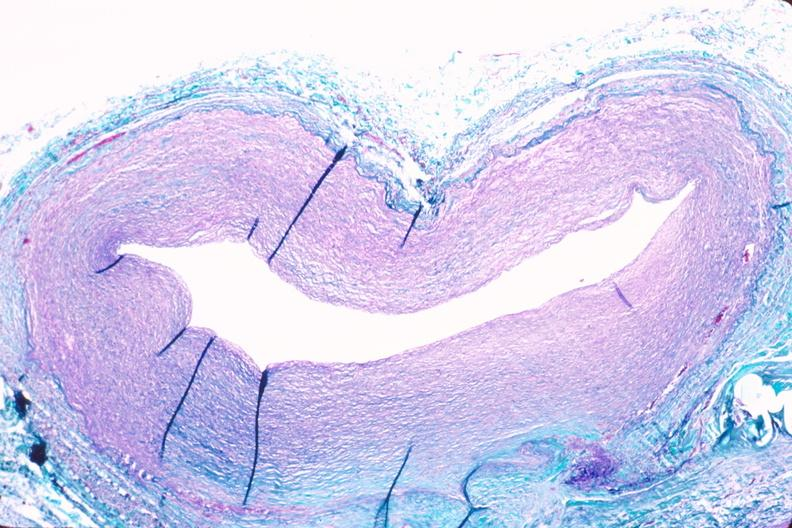what is present?
Answer the question using a single word or phrase. Vasculature 